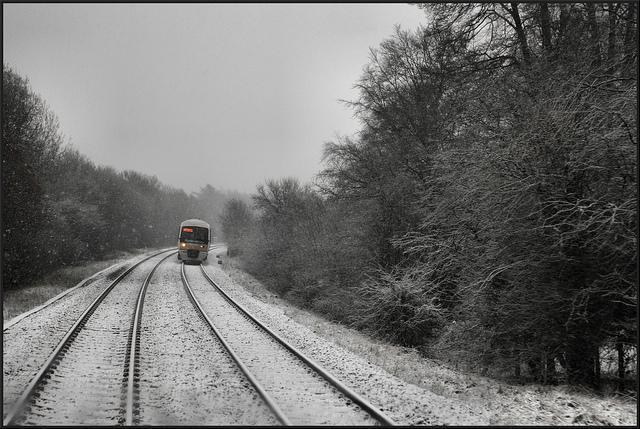How many trains are on the tracks?
Give a very brief answer. 1. How many people are wearing orange on the court?
Give a very brief answer. 0. 